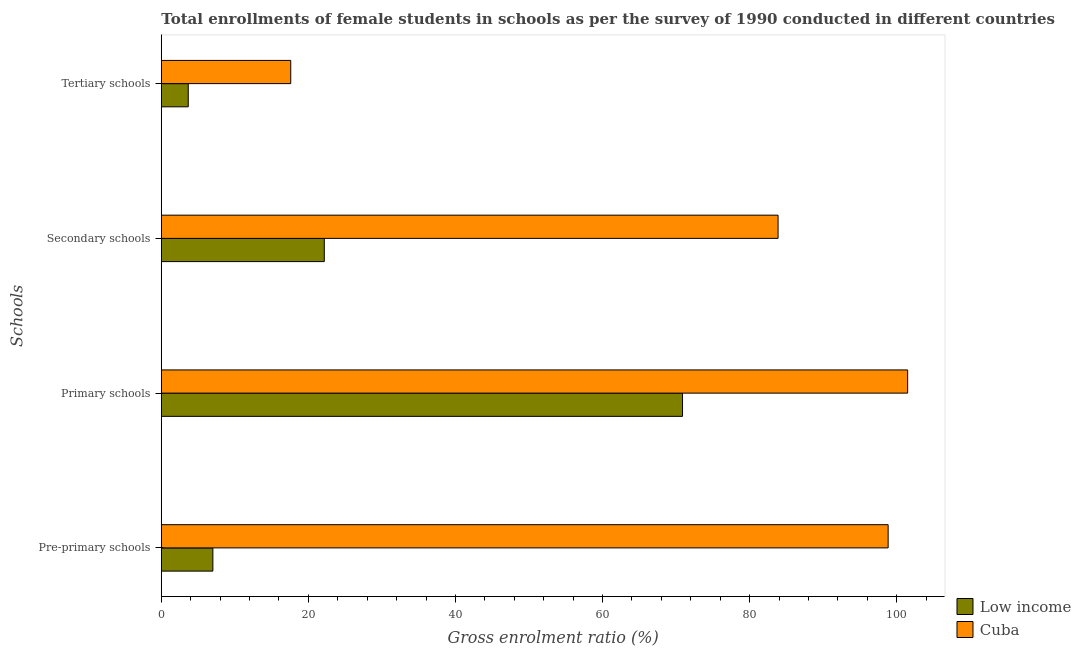How many different coloured bars are there?
Your answer should be very brief. 2. Are the number of bars per tick equal to the number of legend labels?
Make the answer very short. Yes. Are the number of bars on each tick of the Y-axis equal?
Make the answer very short. Yes. How many bars are there on the 2nd tick from the top?
Offer a very short reply. 2. What is the label of the 2nd group of bars from the top?
Give a very brief answer. Secondary schools. What is the gross enrolment ratio(female) in pre-primary schools in Low income?
Provide a short and direct response. 7.01. Across all countries, what is the maximum gross enrolment ratio(female) in tertiary schools?
Make the answer very short. 17.6. Across all countries, what is the minimum gross enrolment ratio(female) in secondary schools?
Offer a very short reply. 22.16. In which country was the gross enrolment ratio(female) in tertiary schools maximum?
Keep it short and to the point. Cuba. What is the total gross enrolment ratio(female) in primary schools in the graph?
Make the answer very short. 172.36. What is the difference between the gross enrolment ratio(female) in primary schools in Low income and that in Cuba?
Offer a terse response. -30.61. What is the difference between the gross enrolment ratio(female) in secondary schools in Cuba and the gross enrolment ratio(female) in primary schools in Low income?
Your response must be concise. 12.99. What is the average gross enrolment ratio(female) in secondary schools per country?
Make the answer very short. 53.01. What is the difference between the gross enrolment ratio(female) in primary schools and gross enrolment ratio(female) in secondary schools in Low income?
Provide a succinct answer. 48.71. In how many countries, is the gross enrolment ratio(female) in secondary schools greater than 28 %?
Make the answer very short. 1. What is the ratio of the gross enrolment ratio(female) in pre-primary schools in Cuba to that in Low income?
Make the answer very short. 14.1. Is the gross enrolment ratio(female) in tertiary schools in Cuba less than that in Low income?
Keep it short and to the point. No. What is the difference between the highest and the second highest gross enrolment ratio(female) in tertiary schools?
Give a very brief answer. 13.94. What is the difference between the highest and the lowest gross enrolment ratio(female) in primary schools?
Your answer should be very brief. 30.61. Is it the case that in every country, the sum of the gross enrolment ratio(female) in pre-primary schools and gross enrolment ratio(female) in tertiary schools is greater than the sum of gross enrolment ratio(female) in primary schools and gross enrolment ratio(female) in secondary schools?
Give a very brief answer. No. What does the 2nd bar from the top in Primary schools represents?
Your answer should be compact. Low income. What does the 2nd bar from the bottom in Pre-primary schools represents?
Provide a succinct answer. Cuba. Is it the case that in every country, the sum of the gross enrolment ratio(female) in pre-primary schools and gross enrolment ratio(female) in primary schools is greater than the gross enrolment ratio(female) in secondary schools?
Your answer should be compact. Yes. How many countries are there in the graph?
Offer a very short reply. 2. What is the difference between two consecutive major ticks on the X-axis?
Provide a short and direct response. 20. Are the values on the major ticks of X-axis written in scientific E-notation?
Make the answer very short. No. Does the graph contain grids?
Keep it short and to the point. No. How are the legend labels stacked?
Your answer should be very brief. Vertical. What is the title of the graph?
Provide a succinct answer. Total enrollments of female students in schools as per the survey of 1990 conducted in different countries. What is the label or title of the X-axis?
Provide a succinct answer. Gross enrolment ratio (%). What is the label or title of the Y-axis?
Your answer should be compact. Schools. What is the Gross enrolment ratio (%) in Low income in Pre-primary schools?
Ensure brevity in your answer.  7.01. What is the Gross enrolment ratio (%) of Cuba in Pre-primary schools?
Keep it short and to the point. 98.83. What is the Gross enrolment ratio (%) in Low income in Primary schools?
Ensure brevity in your answer.  70.87. What is the Gross enrolment ratio (%) of Cuba in Primary schools?
Ensure brevity in your answer.  101.48. What is the Gross enrolment ratio (%) in Low income in Secondary schools?
Offer a terse response. 22.16. What is the Gross enrolment ratio (%) of Cuba in Secondary schools?
Your answer should be compact. 83.87. What is the Gross enrolment ratio (%) in Low income in Tertiary schools?
Your response must be concise. 3.66. What is the Gross enrolment ratio (%) in Cuba in Tertiary schools?
Ensure brevity in your answer.  17.6. Across all Schools, what is the maximum Gross enrolment ratio (%) in Low income?
Keep it short and to the point. 70.87. Across all Schools, what is the maximum Gross enrolment ratio (%) in Cuba?
Keep it short and to the point. 101.48. Across all Schools, what is the minimum Gross enrolment ratio (%) in Low income?
Provide a short and direct response. 3.66. Across all Schools, what is the minimum Gross enrolment ratio (%) of Cuba?
Offer a very short reply. 17.6. What is the total Gross enrolment ratio (%) of Low income in the graph?
Provide a succinct answer. 103.7. What is the total Gross enrolment ratio (%) of Cuba in the graph?
Your answer should be compact. 301.78. What is the difference between the Gross enrolment ratio (%) in Low income in Pre-primary schools and that in Primary schools?
Offer a terse response. -63.86. What is the difference between the Gross enrolment ratio (%) of Cuba in Pre-primary schools and that in Primary schools?
Make the answer very short. -2.65. What is the difference between the Gross enrolment ratio (%) of Low income in Pre-primary schools and that in Secondary schools?
Offer a very short reply. -15.15. What is the difference between the Gross enrolment ratio (%) in Cuba in Pre-primary schools and that in Secondary schools?
Make the answer very short. 14.97. What is the difference between the Gross enrolment ratio (%) in Low income in Pre-primary schools and that in Tertiary schools?
Offer a very short reply. 3.35. What is the difference between the Gross enrolment ratio (%) in Cuba in Pre-primary schools and that in Tertiary schools?
Offer a very short reply. 81.23. What is the difference between the Gross enrolment ratio (%) in Low income in Primary schools and that in Secondary schools?
Offer a very short reply. 48.71. What is the difference between the Gross enrolment ratio (%) in Cuba in Primary schools and that in Secondary schools?
Keep it short and to the point. 17.62. What is the difference between the Gross enrolment ratio (%) in Low income in Primary schools and that in Tertiary schools?
Offer a very short reply. 67.21. What is the difference between the Gross enrolment ratio (%) in Cuba in Primary schools and that in Tertiary schools?
Ensure brevity in your answer.  83.89. What is the difference between the Gross enrolment ratio (%) in Low income in Secondary schools and that in Tertiary schools?
Provide a short and direct response. 18.5. What is the difference between the Gross enrolment ratio (%) in Cuba in Secondary schools and that in Tertiary schools?
Provide a short and direct response. 66.27. What is the difference between the Gross enrolment ratio (%) of Low income in Pre-primary schools and the Gross enrolment ratio (%) of Cuba in Primary schools?
Provide a short and direct response. -94.47. What is the difference between the Gross enrolment ratio (%) of Low income in Pre-primary schools and the Gross enrolment ratio (%) of Cuba in Secondary schools?
Give a very brief answer. -76.85. What is the difference between the Gross enrolment ratio (%) of Low income in Pre-primary schools and the Gross enrolment ratio (%) of Cuba in Tertiary schools?
Offer a terse response. -10.59. What is the difference between the Gross enrolment ratio (%) of Low income in Primary schools and the Gross enrolment ratio (%) of Cuba in Secondary schools?
Make the answer very short. -12.99. What is the difference between the Gross enrolment ratio (%) in Low income in Primary schools and the Gross enrolment ratio (%) in Cuba in Tertiary schools?
Make the answer very short. 53.28. What is the difference between the Gross enrolment ratio (%) in Low income in Secondary schools and the Gross enrolment ratio (%) in Cuba in Tertiary schools?
Provide a short and direct response. 4.56. What is the average Gross enrolment ratio (%) in Low income per Schools?
Your answer should be very brief. 25.93. What is the average Gross enrolment ratio (%) in Cuba per Schools?
Provide a succinct answer. 75.44. What is the difference between the Gross enrolment ratio (%) in Low income and Gross enrolment ratio (%) in Cuba in Pre-primary schools?
Offer a terse response. -91.82. What is the difference between the Gross enrolment ratio (%) of Low income and Gross enrolment ratio (%) of Cuba in Primary schools?
Provide a succinct answer. -30.61. What is the difference between the Gross enrolment ratio (%) of Low income and Gross enrolment ratio (%) of Cuba in Secondary schools?
Your answer should be very brief. -61.71. What is the difference between the Gross enrolment ratio (%) of Low income and Gross enrolment ratio (%) of Cuba in Tertiary schools?
Your answer should be compact. -13.94. What is the ratio of the Gross enrolment ratio (%) of Low income in Pre-primary schools to that in Primary schools?
Offer a very short reply. 0.1. What is the ratio of the Gross enrolment ratio (%) of Cuba in Pre-primary schools to that in Primary schools?
Your answer should be very brief. 0.97. What is the ratio of the Gross enrolment ratio (%) of Low income in Pre-primary schools to that in Secondary schools?
Keep it short and to the point. 0.32. What is the ratio of the Gross enrolment ratio (%) of Cuba in Pre-primary schools to that in Secondary schools?
Your answer should be very brief. 1.18. What is the ratio of the Gross enrolment ratio (%) of Low income in Pre-primary schools to that in Tertiary schools?
Your answer should be very brief. 1.91. What is the ratio of the Gross enrolment ratio (%) in Cuba in Pre-primary schools to that in Tertiary schools?
Offer a very short reply. 5.62. What is the ratio of the Gross enrolment ratio (%) in Low income in Primary schools to that in Secondary schools?
Offer a terse response. 3.2. What is the ratio of the Gross enrolment ratio (%) in Cuba in Primary schools to that in Secondary schools?
Provide a short and direct response. 1.21. What is the ratio of the Gross enrolment ratio (%) in Low income in Primary schools to that in Tertiary schools?
Your response must be concise. 19.35. What is the ratio of the Gross enrolment ratio (%) in Cuba in Primary schools to that in Tertiary schools?
Ensure brevity in your answer.  5.77. What is the ratio of the Gross enrolment ratio (%) in Low income in Secondary schools to that in Tertiary schools?
Make the answer very short. 6.05. What is the ratio of the Gross enrolment ratio (%) of Cuba in Secondary schools to that in Tertiary schools?
Provide a succinct answer. 4.77. What is the difference between the highest and the second highest Gross enrolment ratio (%) of Low income?
Keep it short and to the point. 48.71. What is the difference between the highest and the second highest Gross enrolment ratio (%) in Cuba?
Give a very brief answer. 2.65. What is the difference between the highest and the lowest Gross enrolment ratio (%) in Low income?
Offer a very short reply. 67.21. What is the difference between the highest and the lowest Gross enrolment ratio (%) of Cuba?
Provide a short and direct response. 83.89. 